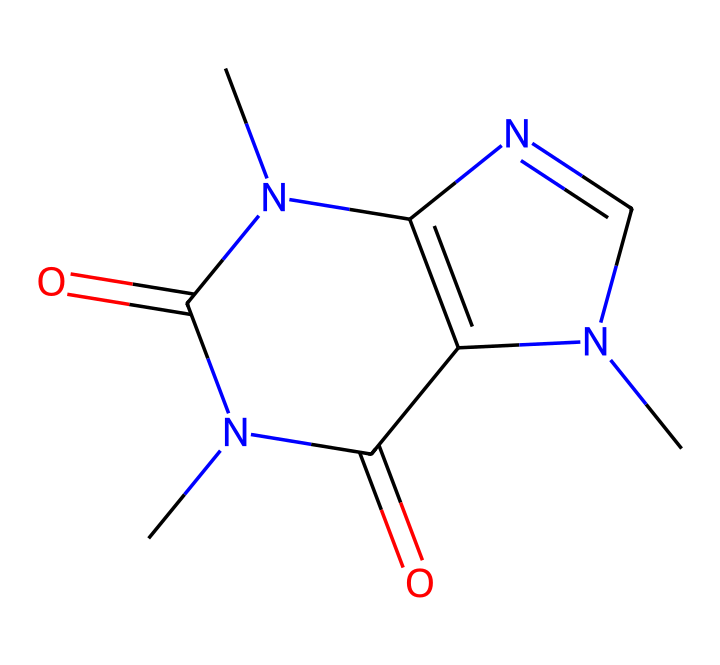What is the primary type of structure found in this caffeine molecule? This molecule is primarily made of carbon, nitrogen, and oxygen atoms, arranged in a ring structure commonly found in alkaloids. The presence of multiple nitrogen atoms and cyclic arrangements defines its classification.
Answer: alkaloid How many nitrogen atoms are in the caffeine structure? By examining the SMILES representation and counting the nitrogen symbols (N), we find that there are three nitrogen atoms present in the entire molecule.
Answer: three What is the total number of carbon atoms in this molecule? The SMILES representation contains seven carbon symbols (C), indicating that there are seven carbon atoms in the caffeine structure.
Answer: seven What type of functional group is present in caffeine? The caffeine molecule contains carbonyl groups (C=O) as it has multiple instances of carbon bound to oxygen with a double bond, characteristic of amides and other organic compounds.
Answer: carbonyl What functional properties does caffeine provide to game day coffee? Caffeine acts as a stimulant by blocking adenosine receptors in the brain, enhancing alertness and reducing fatigue, which is beneficial during high-energy events like games.
Answer: stimulant 